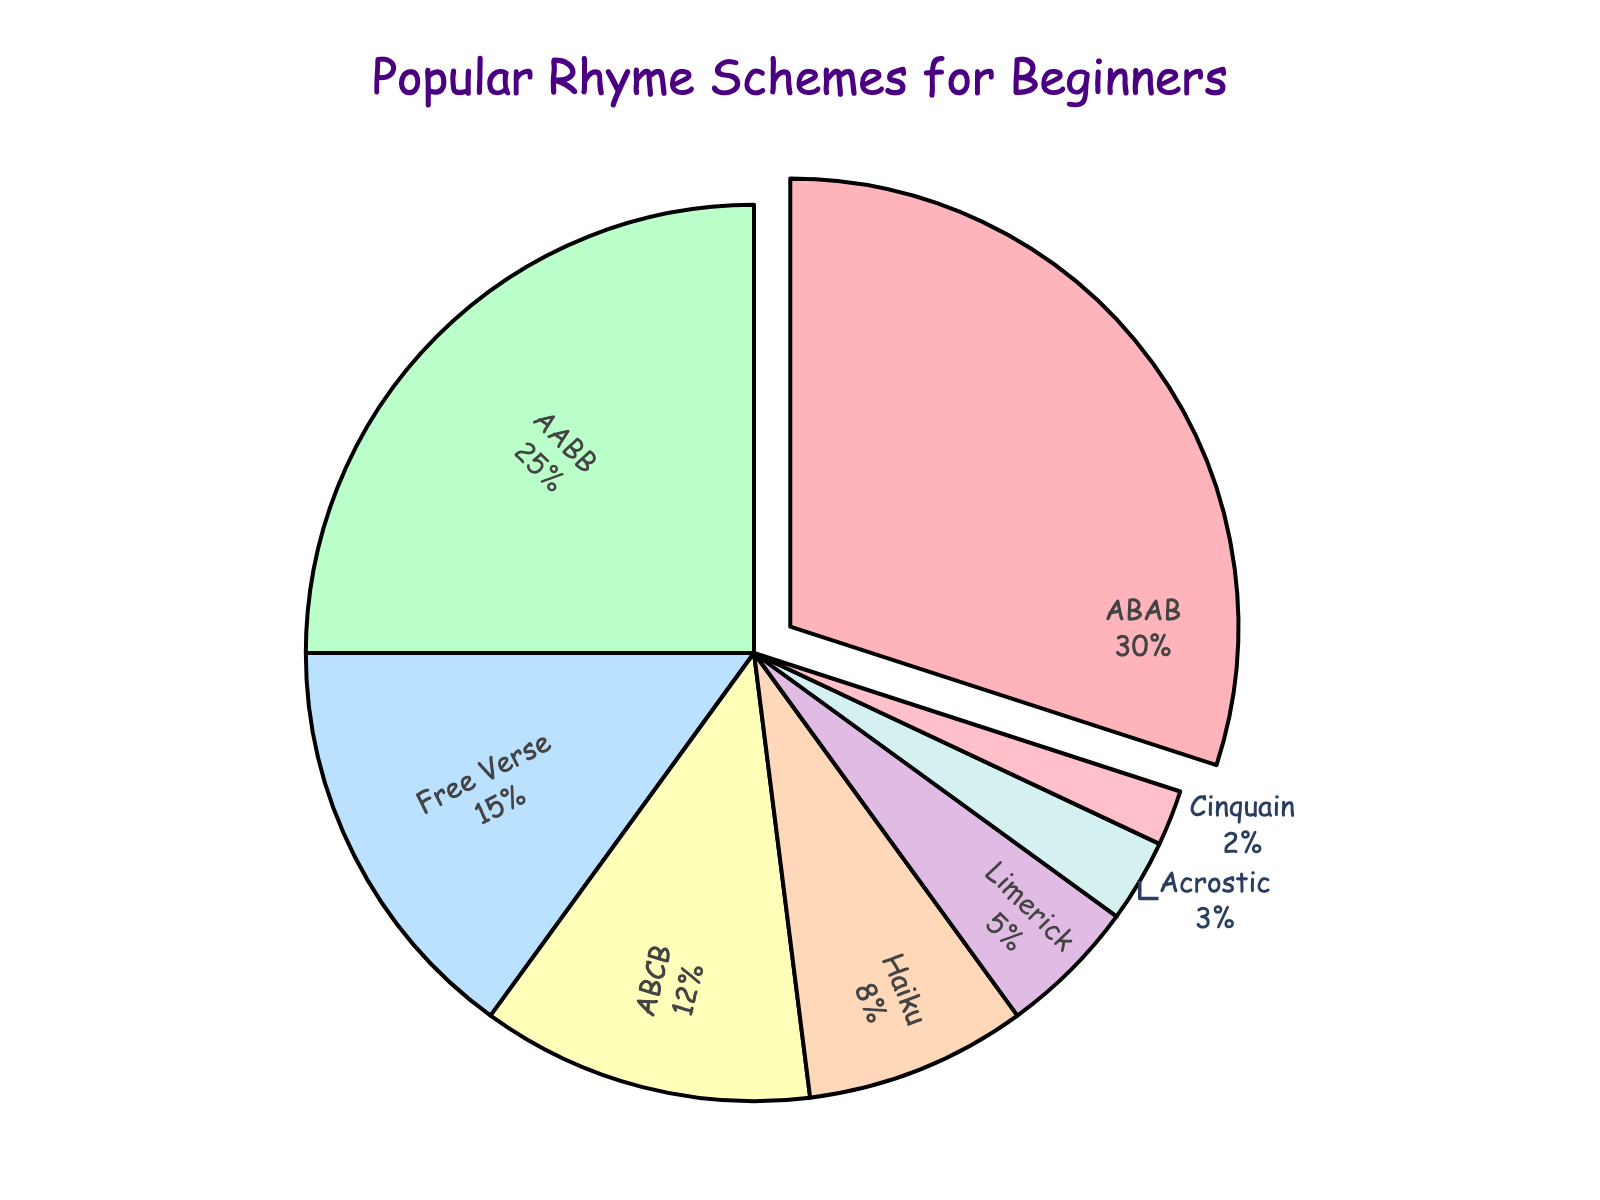What is the most popular rhyme scheme among beginner-level poets? The slice with the highest percentage is labeled "ABAB," and it is pulled out slightly from the pie chart. This indicates that "ABAB" is the most popular rhyme scheme.
Answer: ABAB Which rhyme scheme has the smallest percentage? The smallest slice on the pie chart is labeled "Cinquain," indicating it has the smallest percentage.
Answer: Cinquain How much more popular is the ABAB rhyme scheme compared to the Free Verse rhyme scheme? The percentage for ABAB is 30%, and for Free Verse, it is 15%. The difference can be calculated by subtracting 15% from 30%.
Answer: 15% If we combined the percentages of AABB and ABCB, would they exceed the percentage of ABAB? The percentage for AABB is 25%, and for ABCB, it is 12%. Their combined percentage is 25% + 12% = 37%. Since 37% is greater than 30%, they do exceed ABAB.
Answer: Yes What is the combined percentage of the less common rhyme schemes: Haiku, Limerick, Acrostic, and Cinquain? The percentages for Haiku, Limerick, Acrostic, and Cinquain are 8%, 5%, 3%, and 2%, respectively. Adding these gives us 8% + 5% + 3% + 2% = 18%.
Answer: 18% Which rhyme scheme has a percentage closest to that of Free Verse? The percentage for Free Verse is 15%. The two closest percentages are ABCB at 12% and AABB at 25%. Comparing the differences, Free Verse is closest to ABCB (15% - 12% = 3%).
Answer: ABCB How does the popularity of the Haiku and Limerick rhyme schemes compare? The Haiku has a percentage of 8%, and the Limerick has a percentage of 5%. The Haiku is more popular by 3%.
Answer: Haiku is more popular than Limerick by 3% What percentage of the total does the second most popular rhyme scheme represent? The second most popular rhyme scheme is AABB with 25%.
Answer: 25% Are there more rhyme schemes with a percentage higher than 10% or below 10%? The rhyme schemes with percentages higher than 10% are ABAB (30%), AABB (25%), Free Verse (15%), and ABCB (12%)—a total of 4. The ones below 10% are Haiku (8%), Limerick (5%), Acrostic (3%), and Cinquain (2%)—also a total of 4. Hence, both categories have the same number of rhyme schemes.
Answer: Equal number 